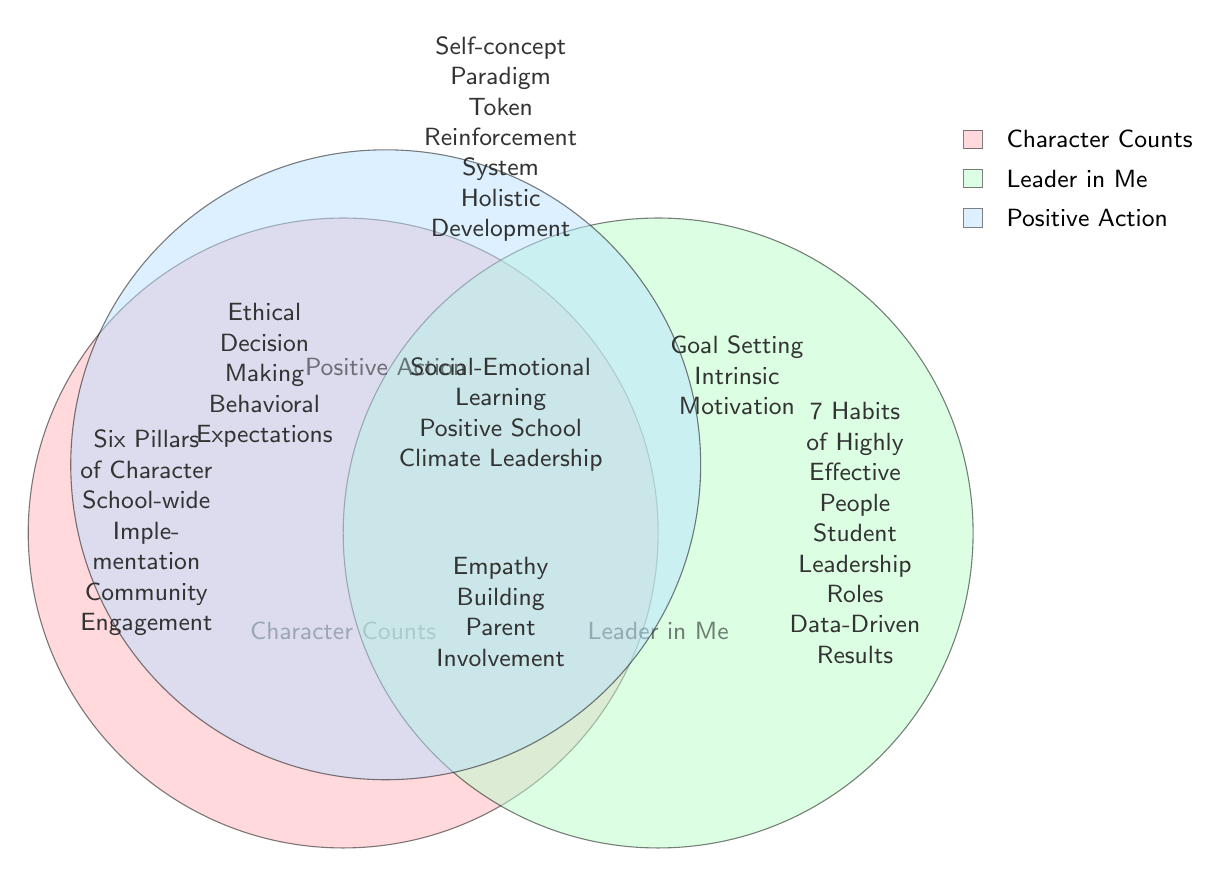What is the unique element of the Character Counts program? The unique elements of the Character Counts program are listed on the left side of the Venn diagram. Since "Six Pillars of Character" corresponds to the Character Counts section, it is identified as its unique element.
Answer: Six Pillars of Character How many unique elements does the Leader in Me program have? The unique elements of the Leader in Me program are indicated on the right side of the Venn diagram. There are three unique elements listed under it, so the counting of those unique elements leads to the answer.
Answer: 3 What overlapping element is associated with both Character Counts and Positive Action? The overlapping section between these two programs is shown in the middle section and lists "Empathy Building" and "Parent Involvement." Understanding that they share common traits leads to identifying these two.
Answer: Empathy Building Which program has elements focused on student leadership? The program "Leader in Me" has unique elements related to student leadership roles. By examining the elements listed under the right circle of the diagram, we can see this focus.
Answer: Leader in Me What is the shared element among all three programs? The center of the Venn diagram displays the elements that are common to all three education programs. Consulting this section, we can find the specific terms listed there.
Answer: Social-Emotional Learning How many total unique elements are presented in the diagram? The diagram exhibits unique elements from each program. By counting the unique elements from all three circles (3 from each), we formulate the total excluding the overlapping sections. The unique counts are three for each.
Answer: 9 What two elements are shared between Leader in Me and Positive Action? By examining the overlapping area between these two segments in the Venn diagram, we identify the elements listed in their intersection, which are both pointing to the same educational focus.
Answer: Goal Setting, Intrinsic Motivation Which character education program emphasizes ethical decision making? The program that emphasizes ethical decision making is indicated in the overlap area between Character Counts and Positive Action. By checking the specific shared elements in that intersection, we find that term.
Answer: Character Counts 